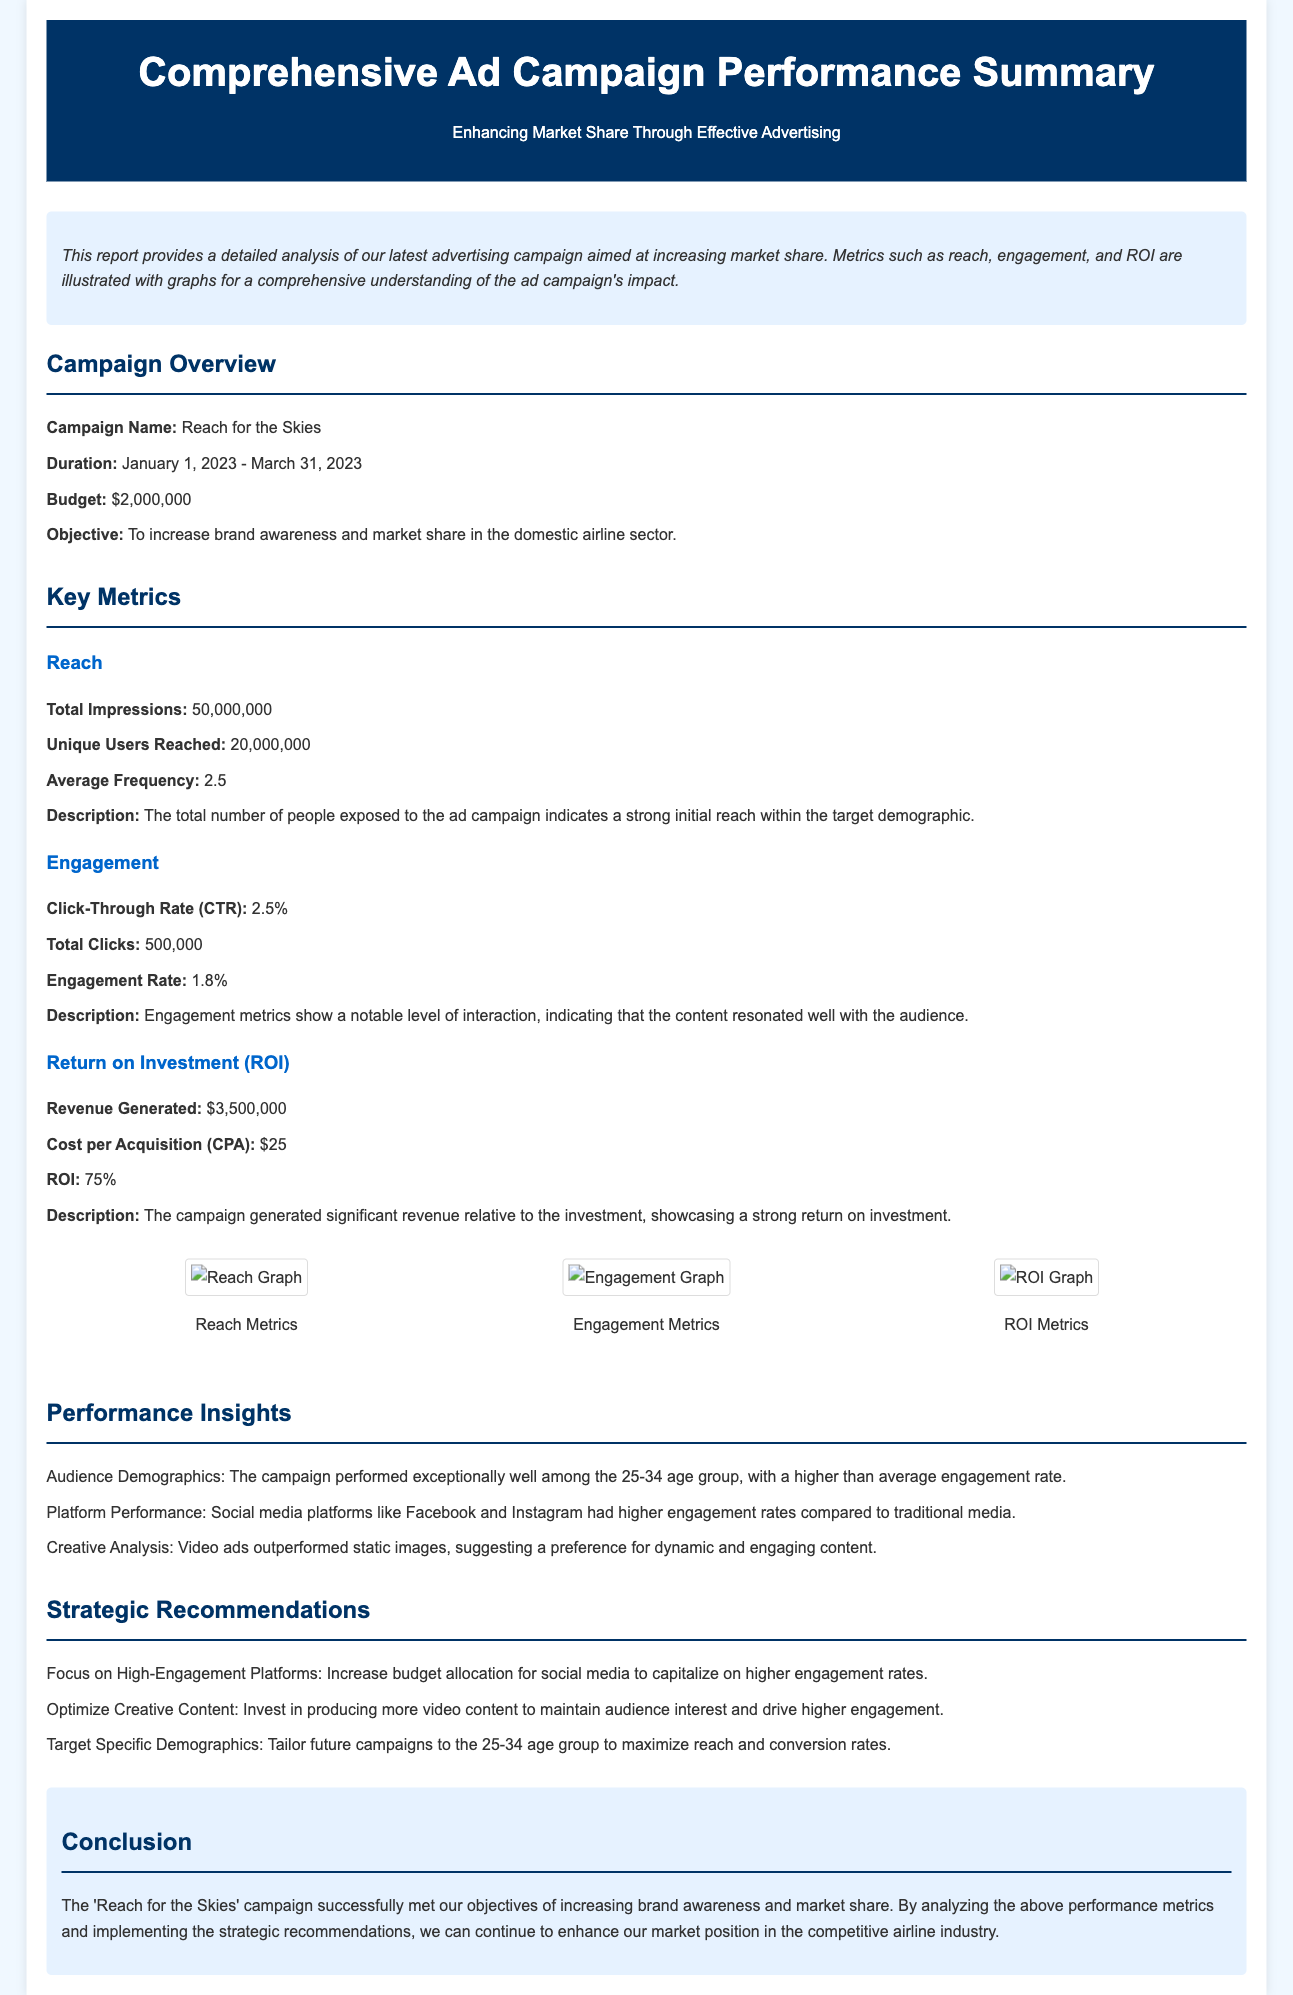what is the campaign name? The campaign name is clearly stated in the overview section of the document.
Answer: Reach for the Skies what was the budget for the campaign? The budget is listed under the campaign overview in the document.
Answer: $2,000,000 how many unique users were reached? The number of unique users reached is outlined in the key metrics section under reach.
Answer: 20,000,000 what was the click-through rate? The click-through rate is mentioned in the engagement metrics section of the document.
Answer: 2.5% what is the return on investment (ROI)? ROI is indicated under the Return on Investment section in the key metrics area.
Answer: 75% which age group performed exceptionally well? The specific age group's performance is highlighted in the performance insights section of the document.
Answer: 25-34 which platforms had higher engagement rates? The platforms with higher engagement rates are specified in the performance insights section.
Answer: Facebook and Instagram what is a strategic recommendation for future campaigns? One of the recommendations is given under the strategic recommendations section of the document.
Answer: Focus on High-Engagement Platforms what is the total revenue generated by the campaign? The total revenue is provided in the ROI section under key metrics.
Answer: $3,500,000 